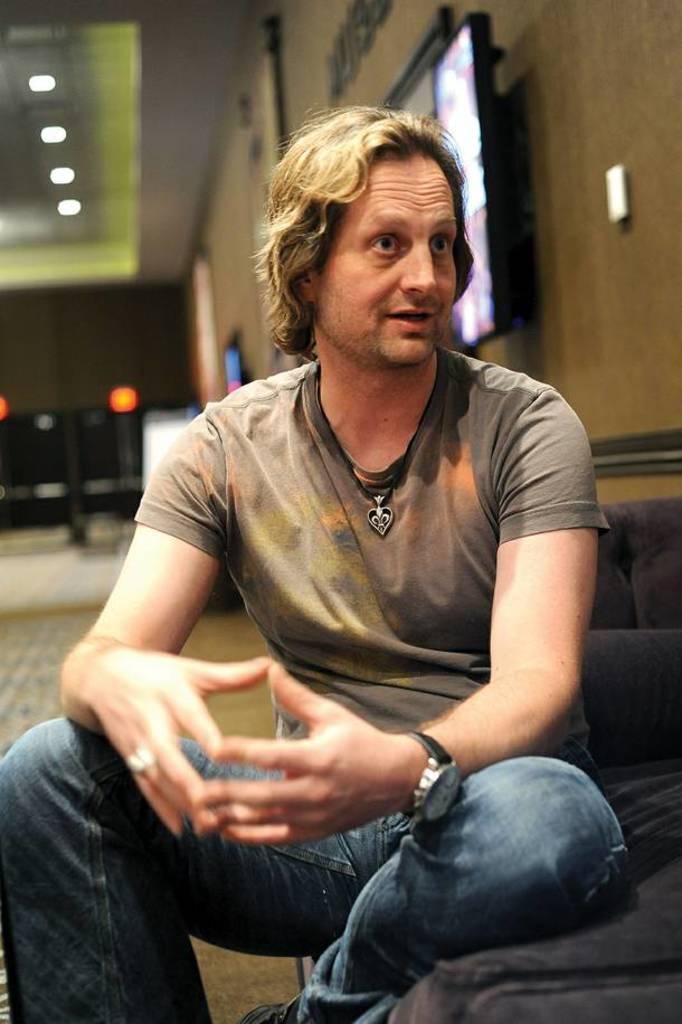How would you summarize this image in a sentence or two? In this picture we can see a man sitting and in the background we can see lights, floor, wall, screens. 